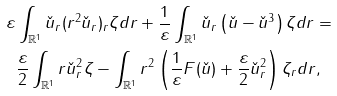Convert formula to latex. <formula><loc_0><loc_0><loc_500><loc_500>\varepsilon & \int _ { \mathbb { R } ^ { 1 } } \check { u } _ { r } ( r ^ { 2 } \check { u } _ { r } ) _ { r } \zeta d r + \frac { 1 } { \varepsilon } \int _ { \mathbb { R } ^ { 1 } } \check { u } _ { r } \left ( \check { u } - \check { u } ^ { 3 } \right ) \zeta d r = \\ & \frac { \varepsilon } { 2 } \int _ { \mathbb { R } ^ { 1 } } r \check { u } ^ { 2 } _ { r } \zeta - \int _ { \mathbb { R } ^ { 1 } } r ^ { 2 } \left ( \frac { 1 } { \varepsilon } F ( \check { u } ) + \frac { \varepsilon } { 2 } \check { u } ^ { 2 } _ { r } \right ) \zeta _ { r } d r ,</formula> 